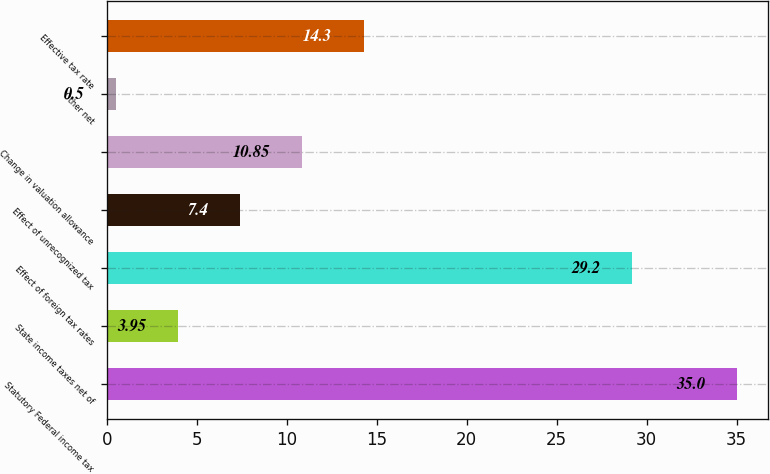Convert chart to OTSL. <chart><loc_0><loc_0><loc_500><loc_500><bar_chart><fcel>Statutory Federal income tax<fcel>State income taxes net of<fcel>Effect of foreign tax rates<fcel>Effect of unrecognized tax<fcel>Change in valuation allowance<fcel>Other net<fcel>Effective tax rate<nl><fcel>35<fcel>3.95<fcel>29.2<fcel>7.4<fcel>10.85<fcel>0.5<fcel>14.3<nl></chart> 